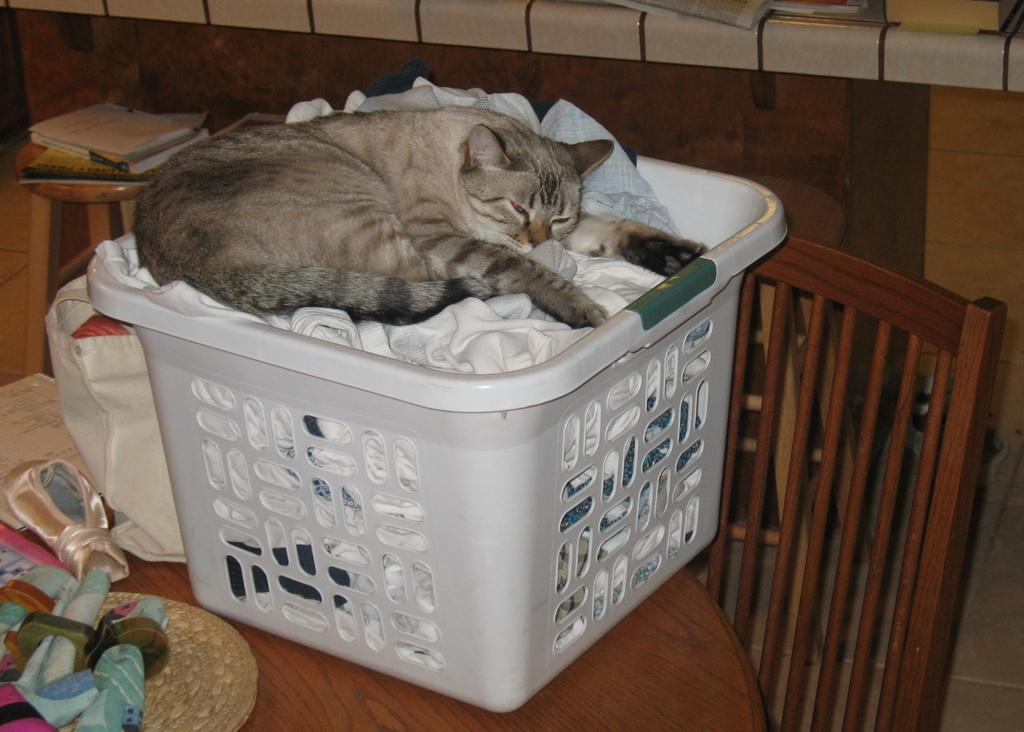What type of animal is in the image? There is a cat in the image. Where is the cat located in the image? The cat is sitting in a basket. What day of the week is the cat's favorite in the image? The image does not provide information about the cat's favorite day of the week. 